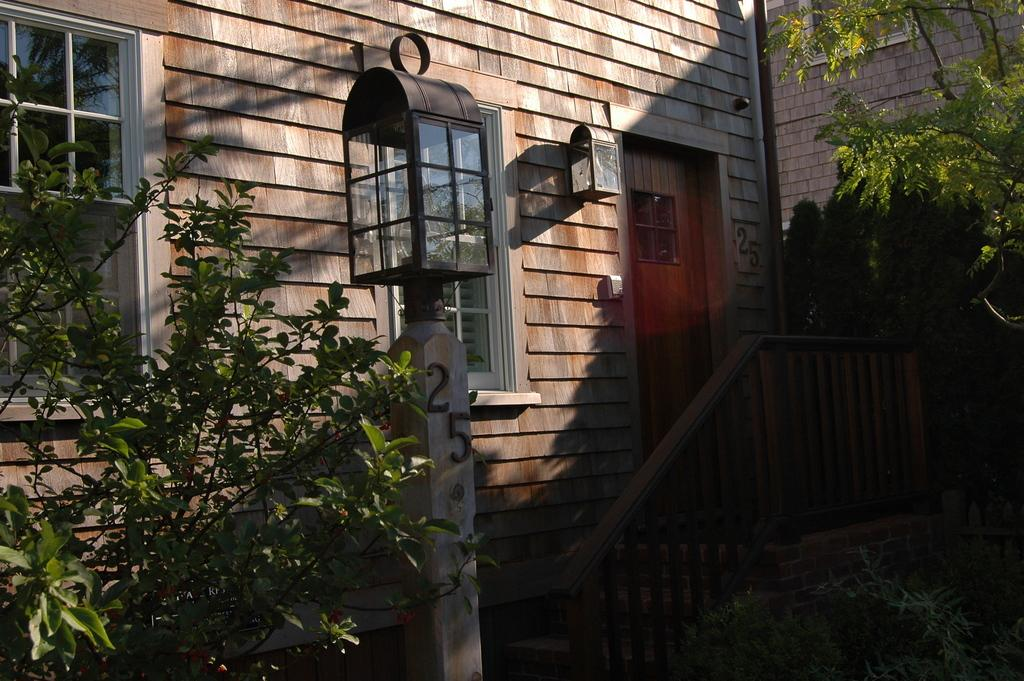What type of structure is visible in the image? There is a building in the image. What else can be seen in the image besides the building? There are plants and a cage on a pole in the image. What type of fish can be seen swimming in the tub in the image? There is no tub or fish present in the image. 